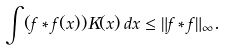<formula> <loc_0><loc_0><loc_500><loc_500>\int ( f \ast f ( x ) ) K ( x ) \, d x \leq \| f \ast f \| _ { \infty } .</formula> 